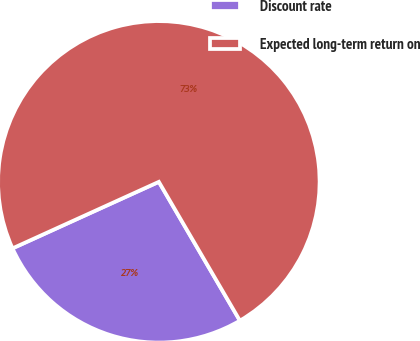<chart> <loc_0><loc_0><loc_500><loc_500><pie_chart><fcel>Discount rate<fcel>Expected long-term return on<nl><fcel>26.62%<fcel>73.38%<nl></chart> 